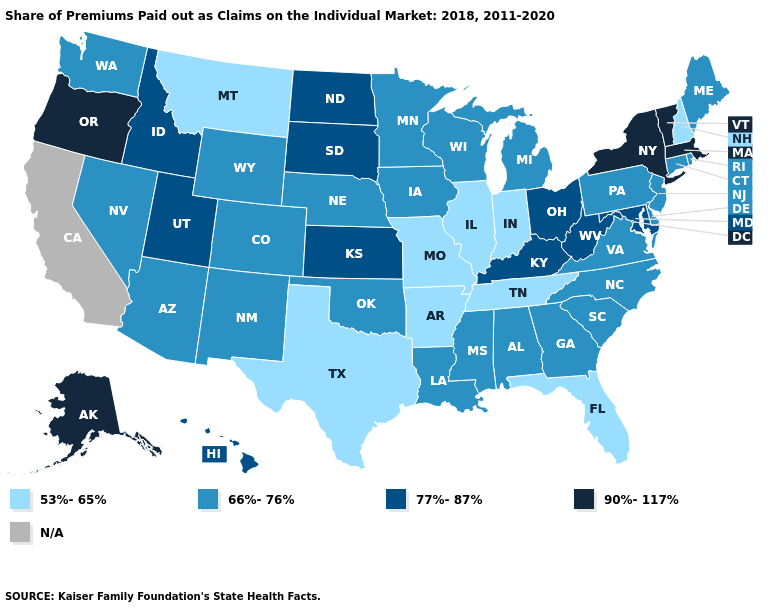What is the value of Delaware?
Be succinct. 66%-76%. Name the states that have a value in the range 77%-87%?
Answer briefly. Hawaii, Idaho, Kansas, Kentucky, Maryland, North Dakota, Ohio, South Dakota, Utah, West Virginia. Which states have the highest value in the USA?
Short answer required. Alaska, Massachusetts, New York, Oregon, Vermont. What is the value of North Carolina?
Be succinct. 66%-76%. What is the value of Nevada?
Give a very brief answer. 66%-76%. Name the states that have a value in the range 66%-76%?
Answer briefly. Alabama, Arizona, Colorado, Connecticut, Delaware, Georgia, Iowa, Louisiana, Maine, Michigan, Minnesota, Mississippi, Nebraska, Nevada, New Jersey, New Mexico, North Carolina, Oklahoma, Pennsylvania, Rhode Island, South Carolina, Virginia, Washington, Wisconsin, Wyoming. Which states have the highest value in the USA?
Short answer required. Alaska, Massachusetts, New York, Oregon, Vermont. Name the states that have a value in the range 66%-76%?
Concise answer only. Alabama, Arizona, Colorado, Connecticut, Delaware, Georgia, Iowa, Louisiana, Maine, Michigan, Minnesota, Mississippi, Nebraska, Nevada, New Jersey, New Mexico, North Carolina, Oklahoma, Pennsylvania, Rhode Island, South Carolina, Virginia, Washington, Wisconsin, Wyoming. What is the value of Idaho?
Answer briefly. 77%-87%. Does the first symbol in the legend represent the smallest category?
Answer briefly. Yes. How many symbols are there in the legend?
Short answer required. 5. Name the states that have a value in the range 53%-65%?
Answer briefly. Arkansas, Florida, Illinois, Indiana, Missouri, Montana, New Hampshire, Tennessee, Texas. Which states have the highest value in the USA?
Give a very brief answer. Alaska, Massachusetts, New York, Oregon, Vermont. Name the states that have a value in the range 66%-76%?
Answer briefly. Alabama, Arizona, Colorado, Connecticut, Delaware, Georgia, Iowa, Louisiana, Maine, Michigan, Minnesota, Mississippi, Nebraska, Nevada, New Jersey, New Mexico, North Carolina, Oklahoma, Pennsylvania, Rhode Island, South Carolina, Virginia, Washington, Wisconsin, Wyoming. 